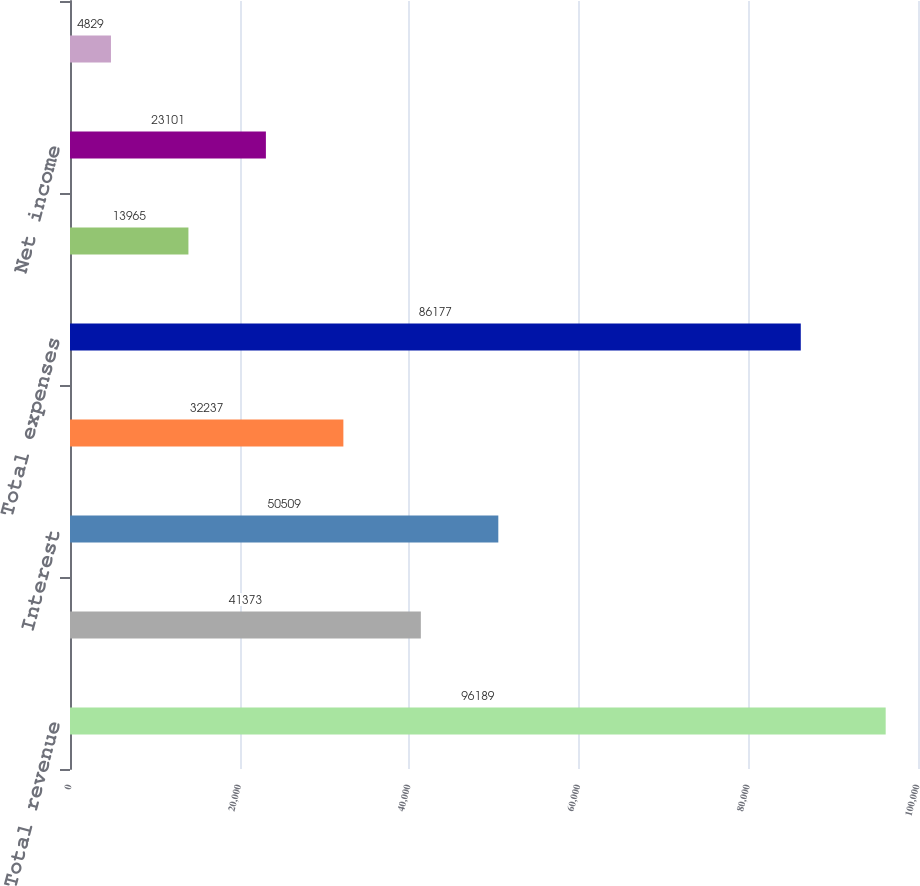Convert chart to OTSL. <chart><loc_0><loc_0><loc_500><loc_500><bar_chart><fcel>Total revenue<fcel>Operating<fcel>Interest<fcel>Depreciation and amortization<fcel>Total expenses<fcel>Income before gain on sale of<fcel>Net income<fcel>Company's share of net income<nl><fcel>96189<fcel>41373<fcel>50509<fcel>32237<fcel>86177<fcel>13965<fcel>23101<fcel>4829<nl></chart> 